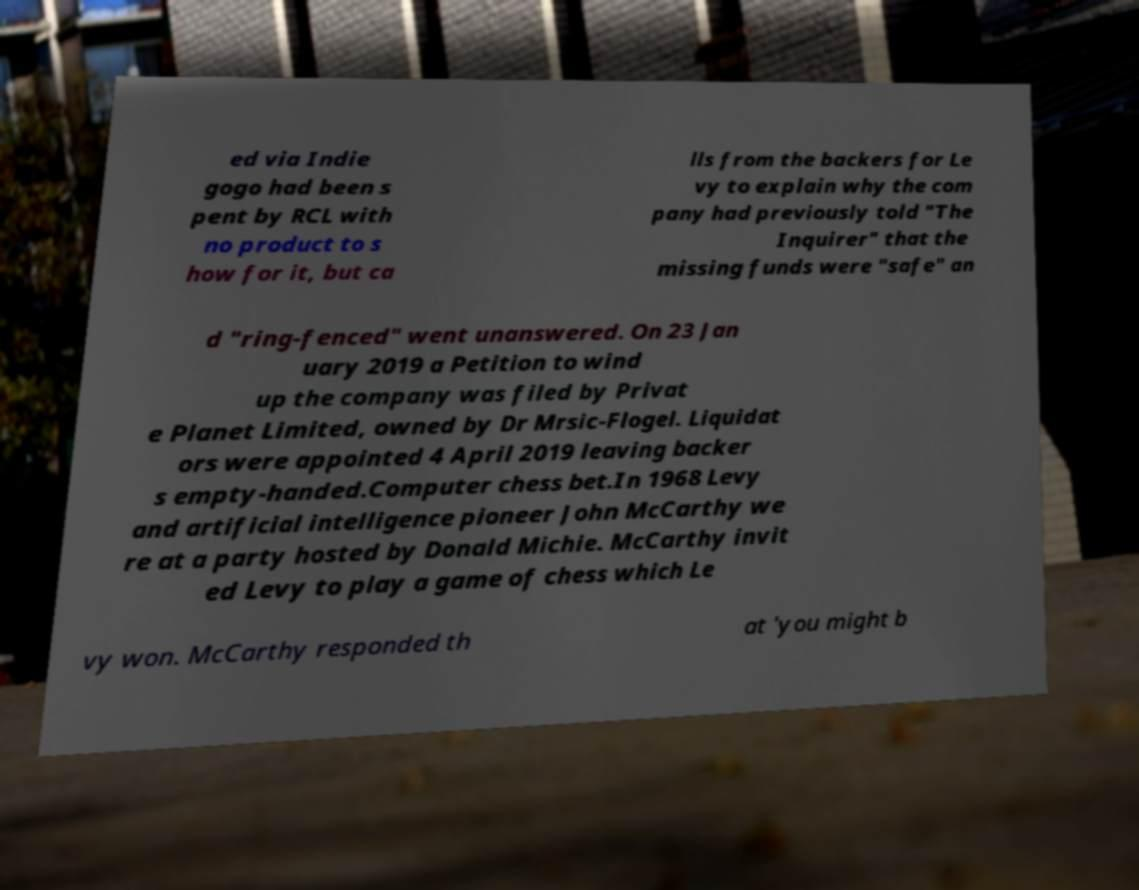For documentation purposes, I need the text within this image transcribed. Could you provide that? ed via Indie gogo had been s pent by RCL with no product to s how for it, but ca lls from the backers for Le vy to explain why the com pany had previously told "The Inquirer" that the missing funds were "safe" an d "ring-fenced" went unanswered. On 23 Jan uary 2019 a Petition to wind up the company was filed by Privat e Planet Limited, owned by Dr Mrsic-Flogel. Liquidat ors were appointed 4 April 2019 leaving backer s empty-handed.Computer chess bet.In 1968 Levy and artificial intelligence pioneer John McCarthy we re at a party hosted by Donald Michie. McCarthy invit ed Levy to play a game of chess which Le vy won. McCarthy responded th at 'you might b 